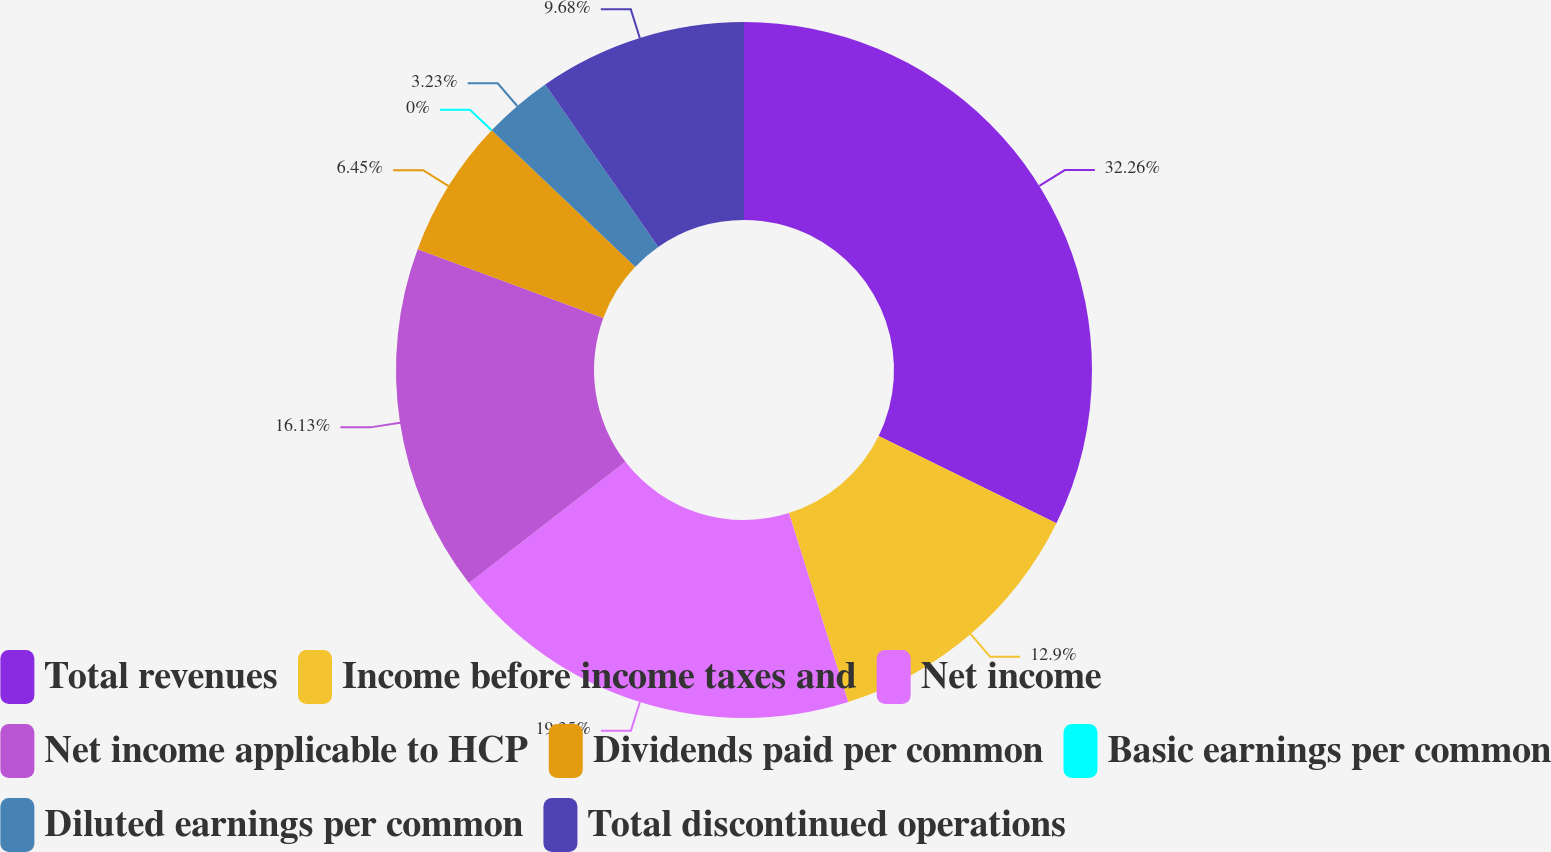Convert chart. <chart><loc_0><loc_0><loc_500><loc_500><pie_chart><fcel>Total revenues<fcel>Income before income taxes and<fcel>Net income<fcel>Net income applicable to HCP<fcel>Dividends paid per common<fcel>Basic earnings per common<fcel>Diluted earnings per common<fcel>Total discontinued operations<nl><fcel>32.26%<fcel>12.9%<fcel>19.35%<fcel>16.13%<fcel>6.45%<fcel>0.0%<fcel>3.23%<fcel>9.68%<nl></chart> 